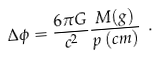<formula> <loc_0><loc_0><loc_500><loc_500>\Delta \phi = \frac { 6 \pi G } { c ^ { 2 } } \frac { M ( g ) } { p \, ( c m ) } \ .</formula> 